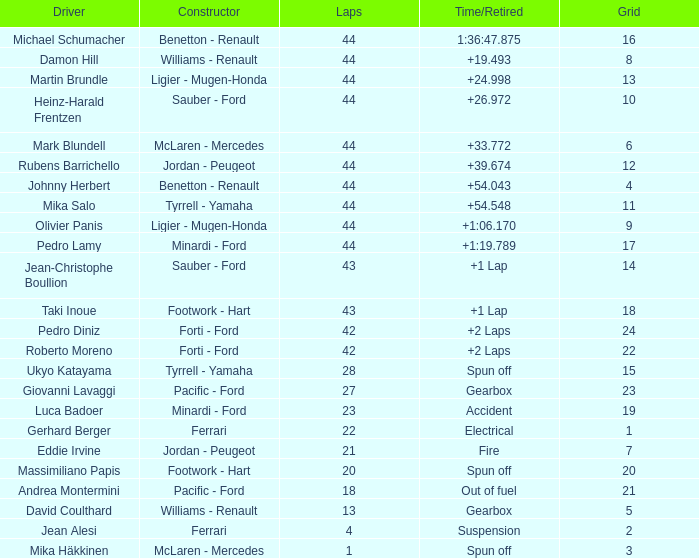What is the high lap total for cards with a grid larger than 21, and a Time/Retired of +2 laps? 42.0. 